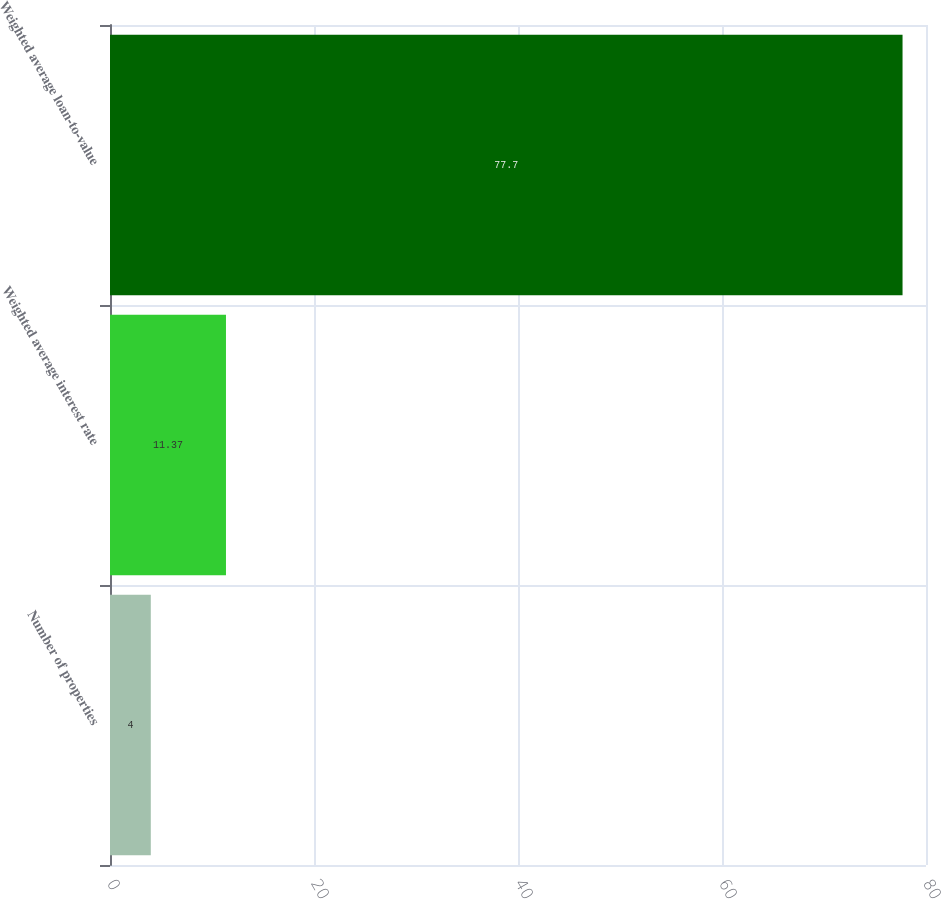<chart> <loc_0><loc_0><loc_500><loc_500><bar_chart><fcel>Number of properties<fcel>Weighted average interest rate<fcel>Weighted average loan-to-value<nl><fcel>4<fcel>11.37<fcel>77.7<nl></chart> 